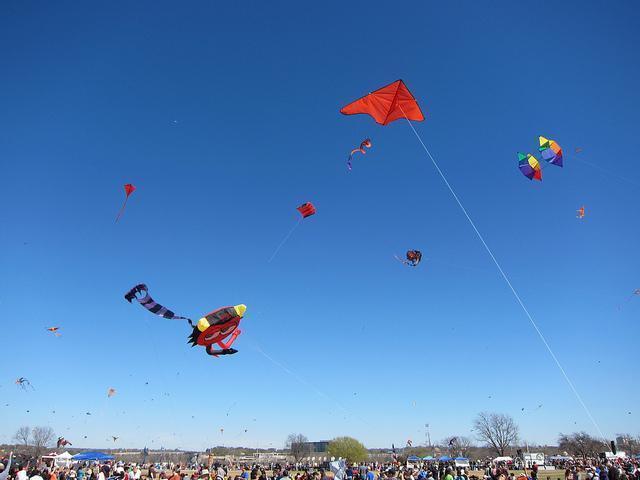How many kites are there?
Give a very brief answer. 3. 